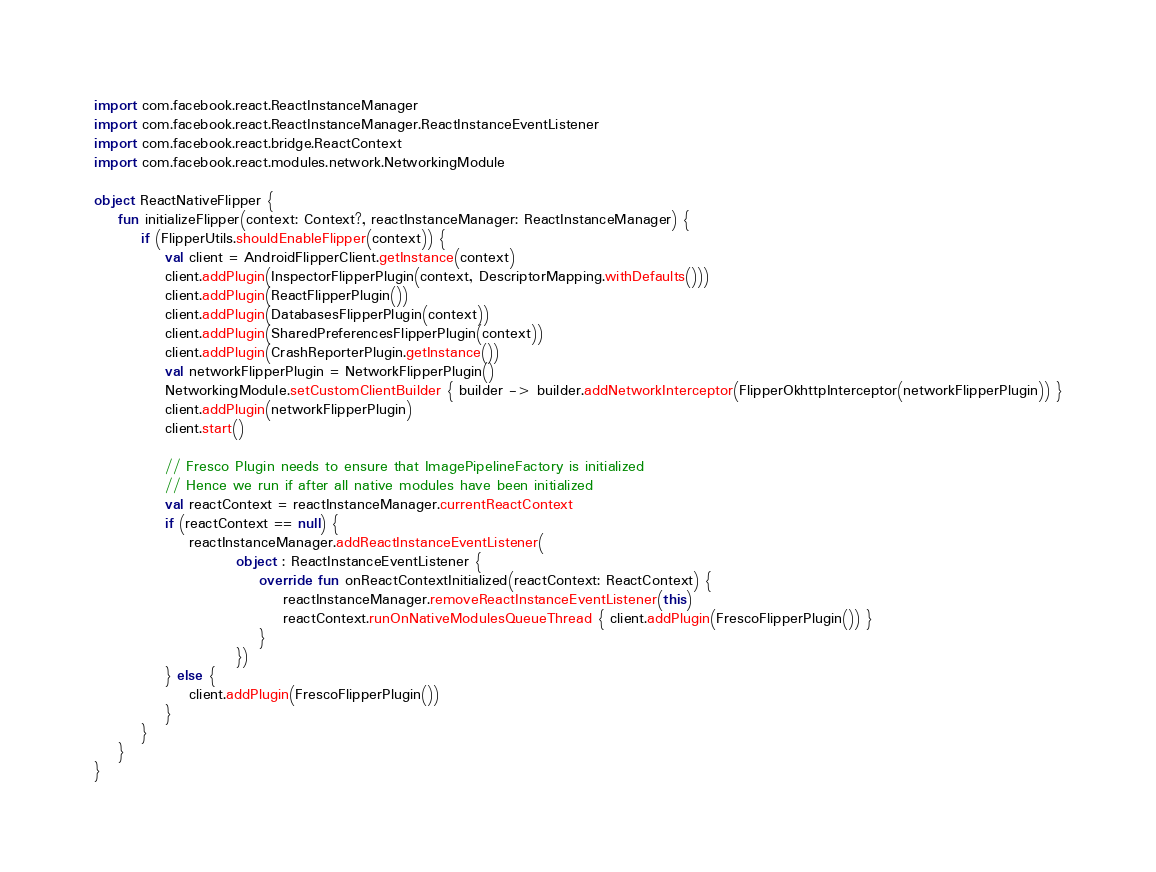Convert code to text. <code><loc_0><loc_0><loc_500><loc_500><_Kotlin_>import com.facebook.react.ReactInstanceManager
import com.facebook.react.ReactInstanceManager.ReactInstanceEventListener
import com.facebook.react.bridge.ReactContext
import com.facebook.react.modules.network.NetworkingModule

object ReactNativeFlipper {
    fun initializeFlipper(context: Context?, reactInstanceManager: ReactInstanceManager) {
        if (FlipperUtils.shouldEnableFlipper(context)) {
            val client = AndroidFlipperClient.getInstance(context)
            client.addPlugin(InspectorFlipperPlugin(context, DescriptorMapping.withDefaults()))
            client.addPlugin(ReactFlipperPlugin())
            client.addPlugin(DatabasesFlipperPlugin(context))
            client.addPlugin(SharedPreferencesFlipperPlugin(context))
            client.addPlugin(CrashReporterPlugin.getInstance())
            val networkFlipperPlugin = NetworkFlipperPlugin()
            NetworkingModule.setCustomClientBuilder { builder -> builder.addNetworkInterceptor(FlipperOkhttpInterceptor(networkFlipperPlugin)) }
            client.addPlugin(networkFlipperPlugin)
            client.start()

            // Fresco Plugin needs to ensure that ImagePipelineFactory is initialized
            // Hence we run if after all native modules have been initialized
            val reactContext = reactInstanceManager.currentReactContext
            if (reactContext == null) {
                reactInstanceManager.addReactInstanceEventListener(
                        object : ReactInstanceEventListener {
                            override fun onReactContextInitialized(reactContext: ReactContext) {
                                reactInstanceManager.removeReactInstanceEventListener(this)
                                reactContext.runOnNativeModulesQueueThread { client.addPlugin(FrescoFlipperPlugin()) }
                            }
                        })
            } else {
                client.addPlugin(FrescoFlipperPlugin())
            }
        }
    }
}</code> 